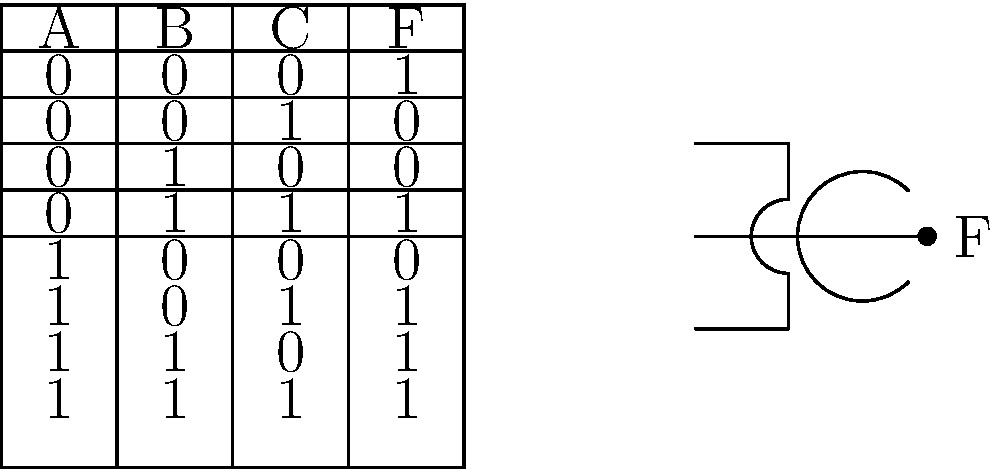Given the truth table for a Boolean function F(A,B,C) and the logic gate configuration shown, determine the Boolean expression for F in terms of A, B, and C. How might this type of logic circuit analysis be relevant to your research in language models for low-resource languages? To solve this problem, we'll follow these steps:

1. Analyze the truth table:
   The output F is 1 when:
   (A,B,C) = (0,0,0), (0,1,1), (1,0,1), (1,1,0), or (1,1,1)

2. Identify the logic gate:
   The gate shown is a 3-input NOR gate.

3. Express F using the NOR gate:
   F = (A + B + C)' (where ' denotes NOT)

4. Use De Morgan's law to expand:
   F = A' · B' · C'

5. Verify with the truth table:
   This expression is true only when A, B, and C are all 0, matching the first row of the truth table.

6. Complete the expression:
   F = A'B'C' + AB'C + A'BC + AB'C + ABC

7. Simplify (optional):
   F = A'B'C' + BC(A + A') + AB'(C + C')
   F = A'B'C' + BC + AB'

Relevance to language model research for low-resource languages:

1. Boolean logic and circuit design principles can be applied to create efficient algorithms for natural language processing tasks.

2. Understanding how to simplify complex logical expressions can help in optimizing language models, especially when working with limited computational resources often encountered in low-resource language scenarios.

3. The process of analyzing and synthesizing logical circuits is analogous to designing and optimizing neural network architectures for language models, which is crucial when dealing with constraints in low-resource settings.

4. The concept of minimizing Boolean functions relates to feature selection and dimensionality reduction in NLP, which are important techniques when working with limited data in low-resource languages.

5. Logic gates and Boolean algebra can be used to model certain linguistic phenomena, potentially aiding in the development of rule-based systems for low-resource languages where data-driven approaches might be limited.
Answer: F = A'B'C' + BC + AB' 